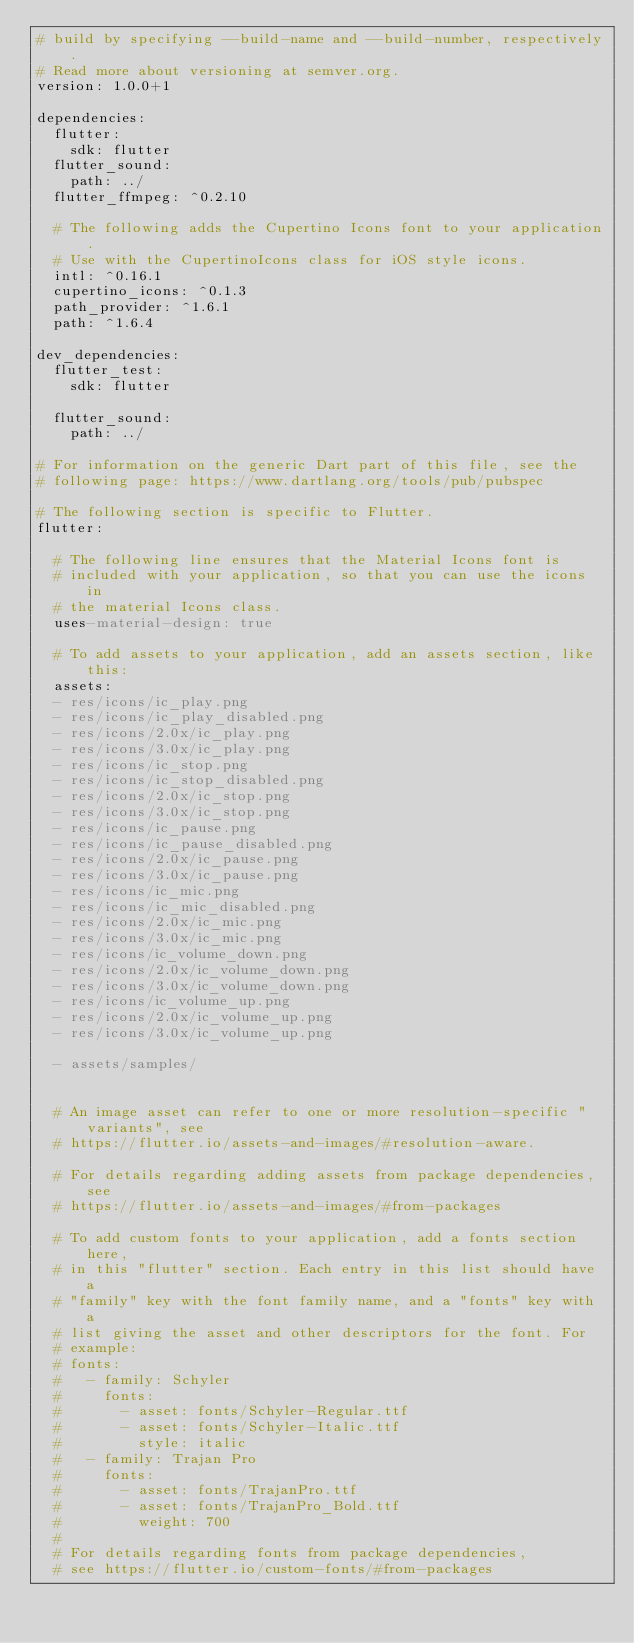<code> <loc_0><loc_0><loc_500><loc_500><_YAML_># build by specifying --build-name and --build-number, respectively.
# Read more about versioning at semver.org.
version: 1.0.0+1

dependencies:
  flutter:
    sdk: flutter
  flutter_sound:
    path: ../
  flutter_ffmpeg: ^0.2.10

  # The following adds the Cupertino Icons font to your application.
  # Use with the CupertinoIcons class for iOS style icons.
  intl: ^0.16.1
  cupertino_icons: ^0.1.3
  path_provider: ^1.6.1
  path: ^1.6.4

dev_dependencies:
  flutter_test:
    sdk: flutter

  flutter_sound:
    path: ../

# For information on the generic Dart part of this file, see the
# following page: https://www.dartlang.org/tools/pub/pubspec

# The following section is specific to Flutter.
flutter:

  # The following line ensures that the Material Icons font is
  # included with your application, so that you can use the icons in
  # the material Icons class.
  uses-material-design: true

  # To add assets to your application, add an assets section, like this:
  assets:
  - res/icons/ic_play.png
  - res/icons/ic_play_disabled.png
  - res/icons/2.0x/ic_play.png
  - res/icons/3.0x/ic_play.png
  - res/icons/ic_stop.png
  - res/icons/ic_stop_disabled.png
  - res/icons/2.0x/ic_stop.png
  - res/icons/3.0x/ic_stop.png
  - res/icons/ic_pause.png
  - res/icons/ic_pause_disabled.png
  - res/icons/2.0x/ic_pause.png
  - res/icons/3.0x/ic_pause.png
  - res/icons/ic_mic.png
  - res/icons/ic_mic_disabled.png
  - res/icons/2.0x/ic_mic.png
  - res/icons/3.0x/ic_mic.png
  - res/icons/ic_volume_down.png
  - res/icons/2.0x/ic_volume_down.png
  - res/icons/3.0x/ic_volume_down.png
  - res/icons/ic_volume_up.png
  - res/icons/2.0x/ic_volume_up.png
  - res/icons/3.0x/ic_volume_up.png
  
  - assets/samples/


  # An image asset can refer to one or more resolution-specific "variants", see
  # https://flutter.io/assets-and-images/#resolution-aware.

  # For details regarding adding assets from package dependencies, see
  # https://flutter.io/assets-and-images/#from-packages

  # To add custom fonts to your application, add a fonts section here,
  # in this "flutter" section. Each entry in this list should have a
  # "family" key with the font family name, and a "fonts" key with a
  # list giving the asset and other descriptors for the font. For
  # example:
  # fonts:
  #   - family: Schyler
  #     fonts:
  #       - asset: fonts/Schyler-Regular.ttf
  #       - asset: fonts/Schyler-Italic.ttf
  #         style: italic
  #   - family: Trajan Pro
  #     fonts:
  #       - asset: fonts/TrajanPro.ttf
  #       - asset: fonts/TrajanPro_Bold.ttf
  #         weight: 700
  #
  # For details regarding fonts from package dependencies,
  # see https://flutter.io/custom-fonts/#from-packages
</code> 